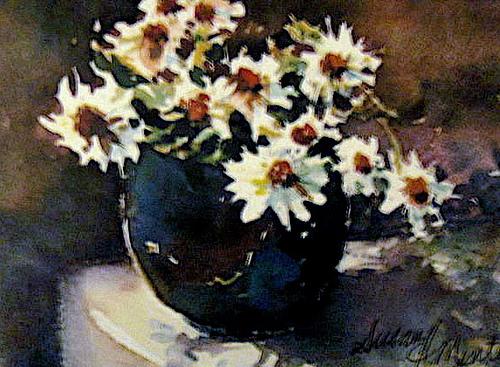Is this a photograph or painting?
Concise answer only. Painting. What is the color of the flowers?
Short answer required. White. Who painted the painting?
Concise answer only. Susan. 